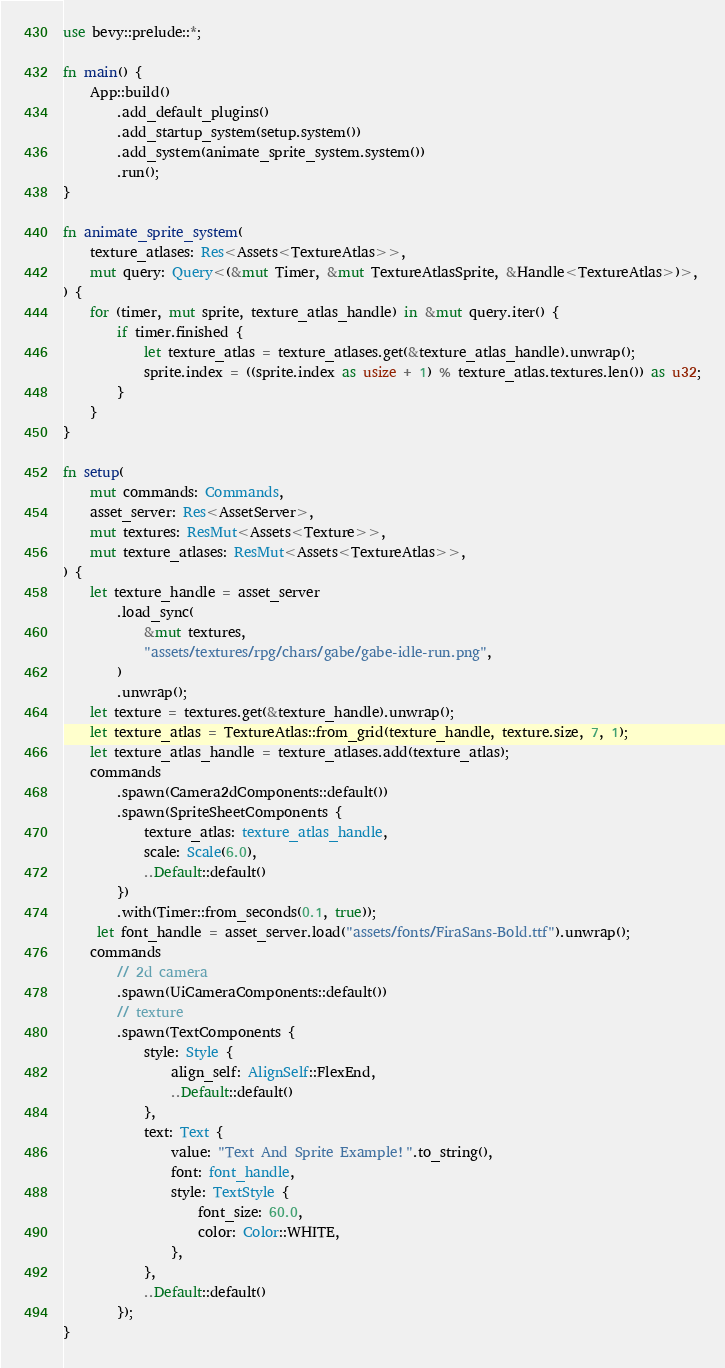Convert code to text. <code><loc_0><loc_0><loc_500><loc_500><_Rust_>use bevy::prelude::*;

fn main() {
    App::build()
        .add_default_plugins()
        .add_startup_system(setup.system())
        .add_system(animate_sprite_system.system())
        .run();
}

fn animate_sprite_system(
    texture_atlases: Res<Assets<TextureAtlas>>,
    mut query: Query<(&mut Timer, &mut TextureAtlasSprite, &Handle<TextureAtlas>)>,
) {
    for (timer, mut sprite, texture_atlas_handle) in &mut query.iter() {
        if timer.finished {
            let texture_atlas = texture_atlases.get(&texture_atlas_handle).unwrap();
            sprite.index = ((sprite.index as usize + 1) % texture_atlas.textures.len()) as u32;
        }
    }
}

fn setup(
    mut commands: Commands,
    asset_server: Res<AssetServer>,
    mut textures: ResMut<Assets<Texture>>,
    mut texture_atlases: ResMut<Assets<TextureAtlas>>,
) {
    let texture_handle = asset_server
        .load_sync(
            &mut textures,
            "assets/textures/rpg/chars/gabe/gabe-idle-run.png",
        )
        .unwrap();
    let texture = textures.get(&texture_handle).unwrap();
    let texture_atlas = TextureAtlas::from_grid(texture_handle, texture.size, 7, 1);
    let texture_atlas_handle = texture_atlases.add(texture_atlas);
    commands
        .spawn(Camera2dComponents::default())
        .spawn(SpriteSheetComponents {
            texture_atlas: texture_atlas_handle,
            scale: Scale(6.0),
            ..Default::default()
        })
        .with(Timer::from_seconds(0.1, true));
     let font_handle = asset_server.load("assets/fonts/FiraSans-Bold.ttf").unwrap();
    commands
        // 2d camera
        .spawn(UiCameraComponents::default())
        // texture
        .spawn(TextComponents {
            style: Style {
                align_self: AlignSelf::FlexEnd,
                ..Default::default()
            },
            text: Text {
                value: "Text And Sprite Example!".to_string(),
                font: font_handle,
                style: TextStyle {
                    font_size: 60.0,
                    color: Color::WHITE,
                },
            },
            ..Default::default()
        });
}
</code> 